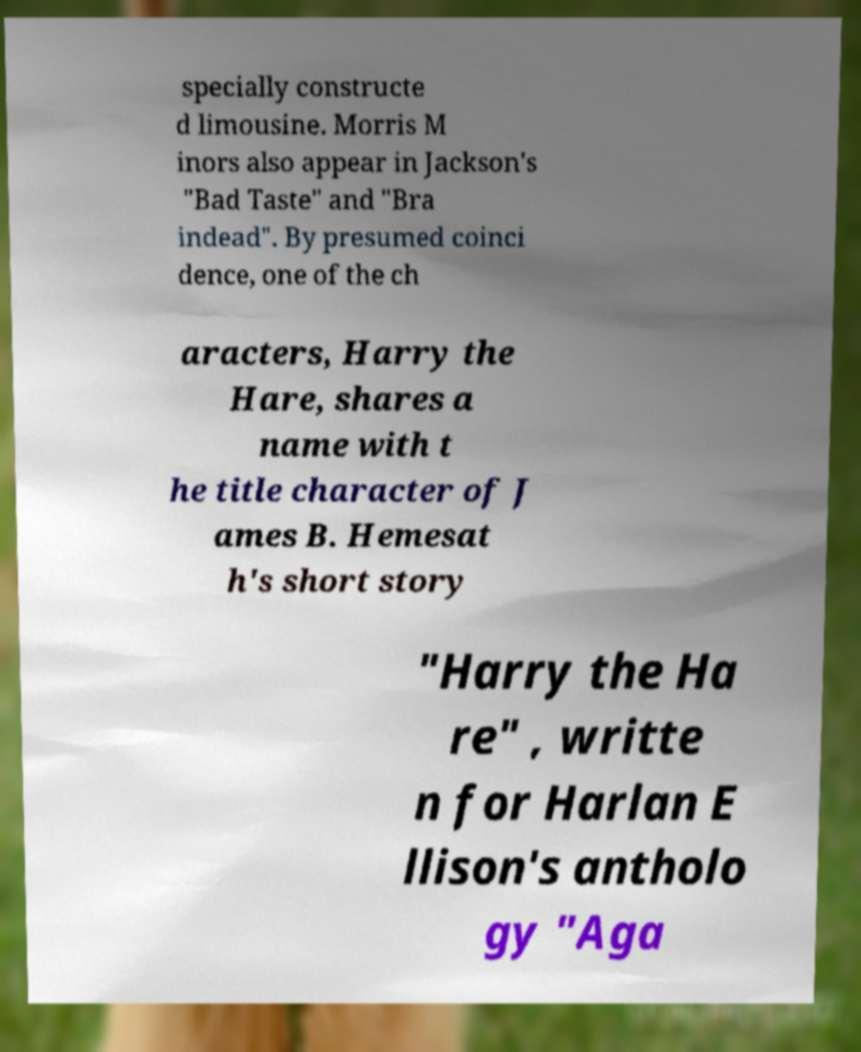Could you assist in decoding the text presented in this image and type it out clearly? specially constructe d limousine. Morris M inors also appear in Jackson's "Bad Taste" and "Bra indead". By presumed coinci dence, one of the ch aracters, Harry the Hare, shares a name with t he title character of J ames B. Hemesat h's short story "Harry the Ha re" , writte n for Harlan E llison's antholo gy "Aga 